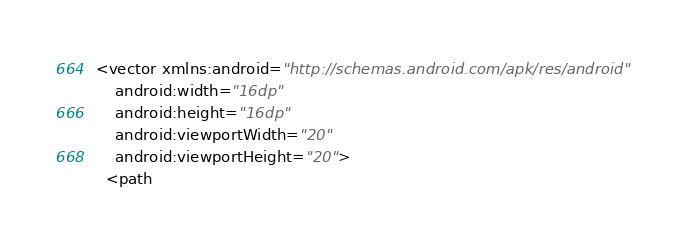Convert code to text. <code><loc_0><loc_0><loc_500><loc_500><_XML_><vector xmlns:android="http://schemas.android.com/apk/res/android"
    android:width="16dp"
    android:height="16dp"
    android:viewportWidth="20"
    android:viewportHeight="20">
  <path</code> 